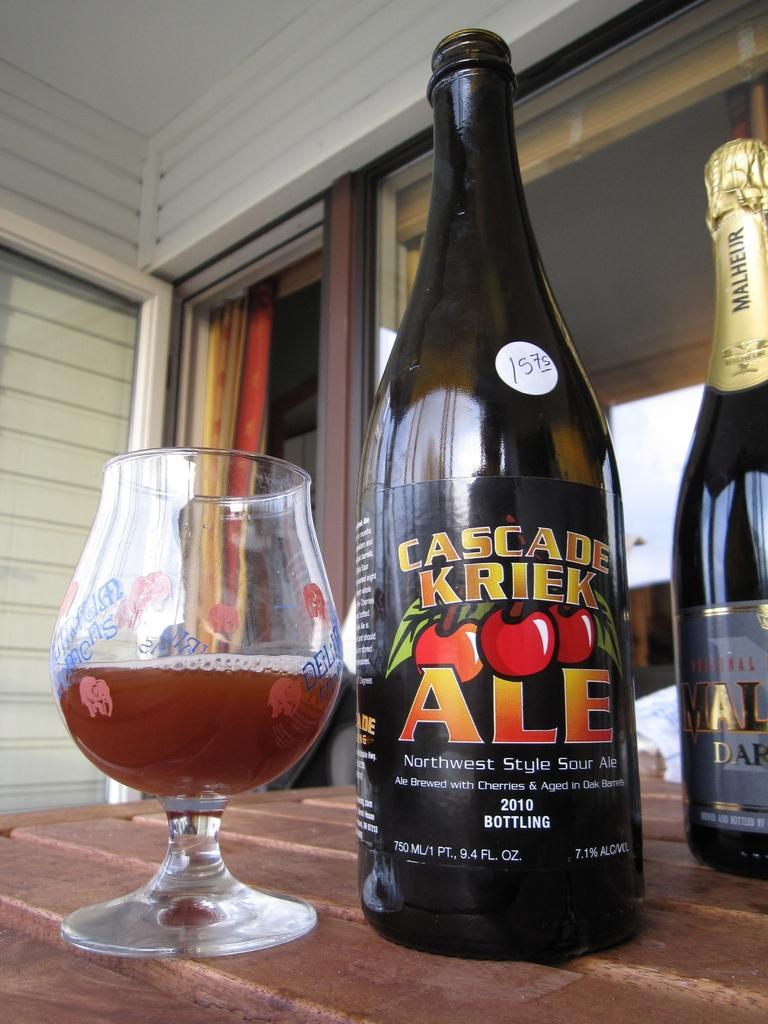<image>
Share a concise interpretation of the image provided. An open bottle of Cascase Kriek Ale is next to a partially filled glass. 